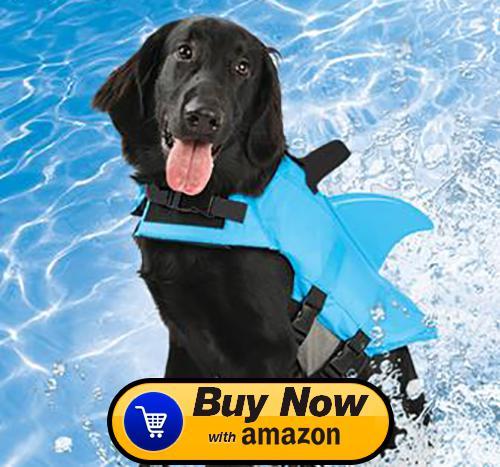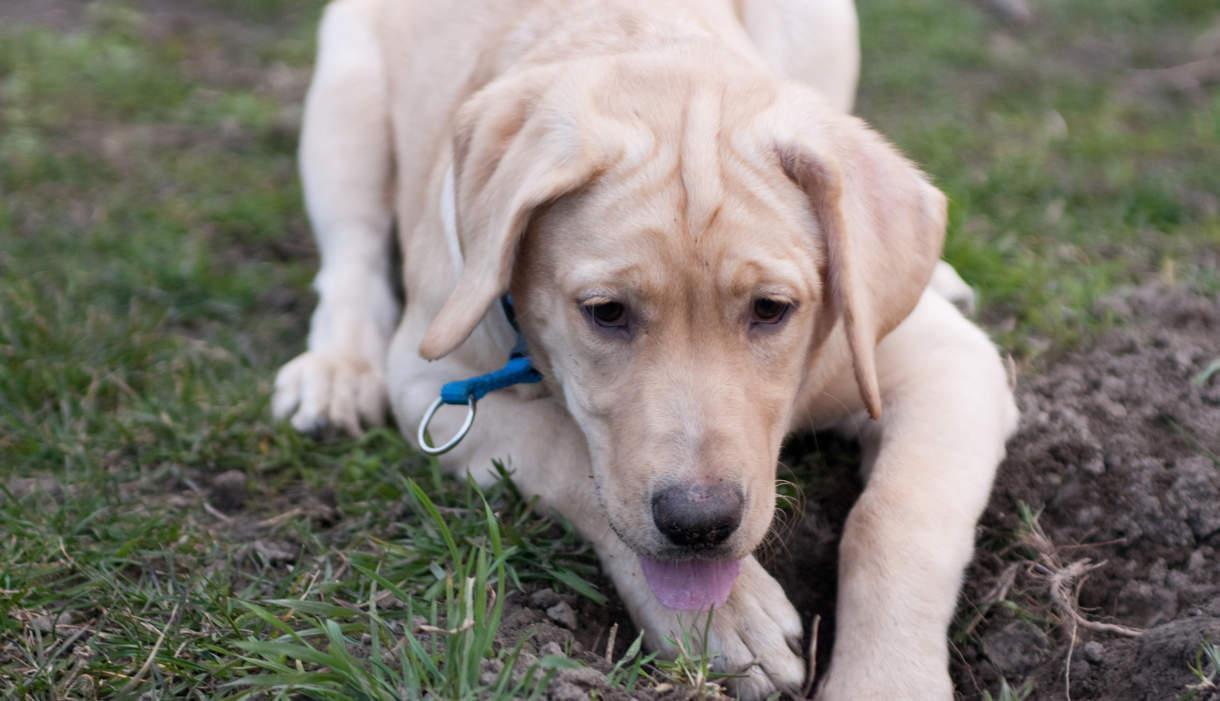The first image is the image on the left, the second image is the image on the right. Evaluate the accuracy of this statement regarding the images: "In at least one image, a dog is in a body of water while wearing a life jacket or flotation device of some kind". Is it true? Answer yes or no. Yes. The first image is the image on the left, the second image is the image on the right. Examine the images to the left and right. Is the description "The left image contains one dog that is black." accurate? Answer yes or no. Yes. 